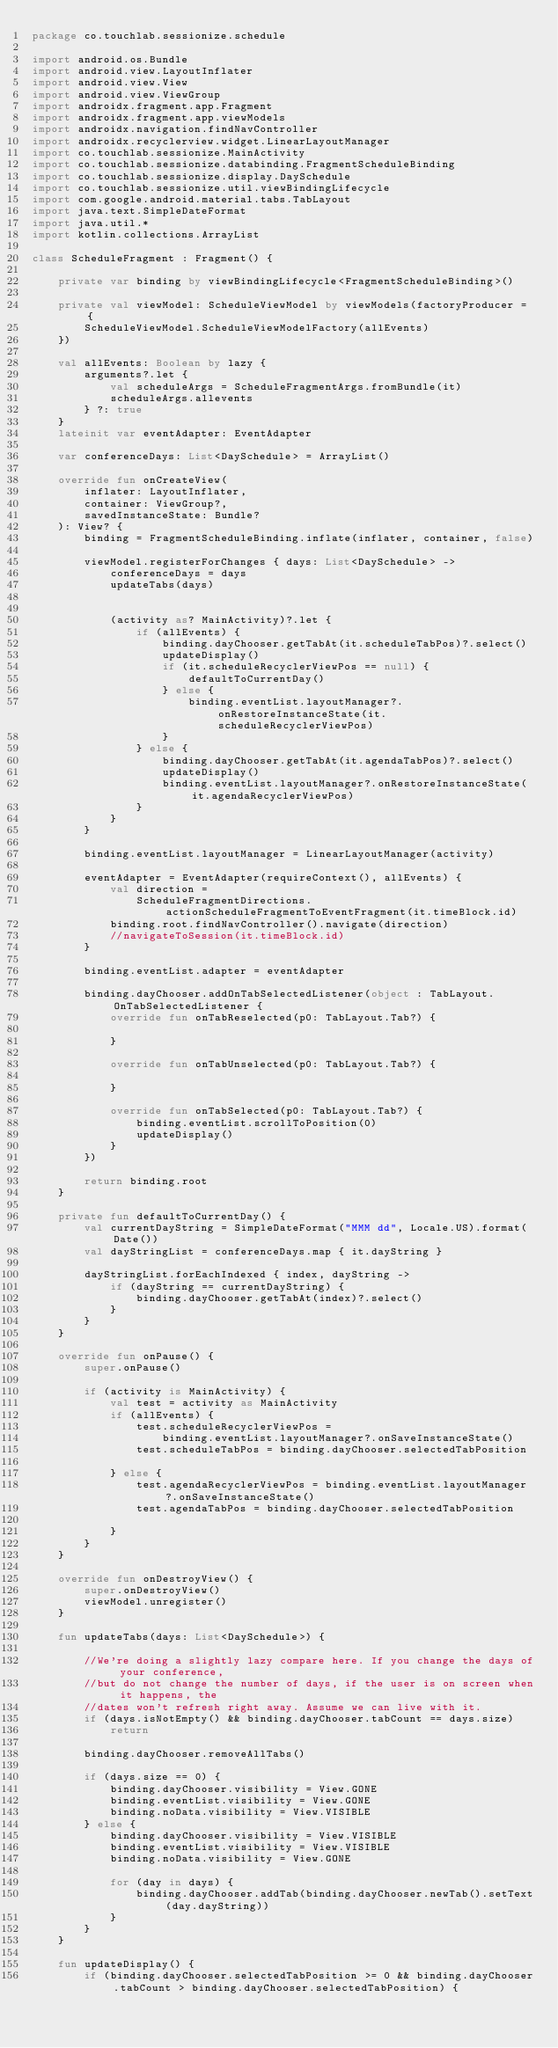<code> <loc_0><loc_0><loc_500><loc_500><_Kotlin_>package co.touchlab.sessionize.schedule

import android.os.Bundle
import android.view.LayoutInflater
import android.view.View
import android.view.ViewGroup
import androidx.fragment.app.Fragment
import androidx.fragment.app.viewModels
import androidx.navigation.findNavController
import androidx.recyclerview.widget.LinearLayoutManager
import co.touchlab.sessionize.MainActivity
import co.touchlab.sessionize.databinding.FragmentScheduleBinding
import co.touchlab.sessionize.display.DaySchedule
import co.touchlab.sessionize.util.viewBindingLifecycle
import com.google.android.material.tabs.TabLayout
import java.text.SimpleDateFormat
import java.util.*
import kotlin.collections.ArrayList

class ScheduleFragment : Fragment() {

    private var binding by viewBindingLifecycle<FragmentScheduleBinding>()

    private val viewModel: ScheduleViewModel by viewModels(factoryProducer = {
        ScheduleViewModel.ScheduleViewModelFactory(allEvents)
    })

    val allEvents: Boolean by lazy {
        arguments?.let {
            val scheduleArgs = ScheduleFragmentArgs.fromBundle(it)
            scheduleArgs.allevents
        } ?: true
    }
    lateinit var eventAdapter: EventAdapter

    var conferenceDays: List<DaySchedule> = ArrayList()

    override fun onCreateView(
        inflater: LayoutInflater,
        container: ViewGroup?,
        savedInstanceState: Bundle?
    ): View? {
        binding = FragmentScheduleBinding.inflate(inflater, container, false)

        viewModel.registerForChanges { days: List<DaySchedule> ->
            conferenceDays = days
            updateTabs(days)


            (activity as? MainActivity)?.let {
                if (allEvents) {
                    binding.dayChooser.getTabAt(it.scheduleTabPos)?.select()
                    updateDisplay()
                    if (it.scheduleRecyclerViewPos == null) {
                        defaultToCurrentDay()
                    } else {
                        binding.eventList.layoutManager?.onRestoreInstanceState(it.scheduleRecyclerViewPos)
                    }
                } else {
                    binding.dayChooser.getTabAt(it.agendaTabPos)?.select()
                    updateDisplay()
                    binding.eventList.layoutManager?.onRestoreInstanceState(it.agendaRecyclerViewPos)
                }
            }
        }

        binding.eventList.layoutManager = LinearLayoutManager(activity)

        eventAdapter = EventAdapter(requireContext(), allEvents) {
            val direction =
                ScheduleFragmentDirections.actionScheduleFragmentToEventFragment(it.timeBlock.id)
            binding.root.findNavController().navigate(direction)
            //navigateToSession(it.timeBlock.id)
        }

        binding.eventList.adapter = eventAdapter

        binding.dayChooser.addOnTabSelectedListener(object : TabLayout.OnTabSelectedListener {
            override fun onTabReselected(p0: TabLayout.Tab?) {

            }

            override fun onTabUnselected(p0: TabLayout.Tab?) {

            }

            override fun onTabSelected(p0: TabLayout.Tab?) {
                binding.eventList.scrollToPosition(0)
                updateDisplay()
            }
        })

        return binding.root
    }

    private fun defaultToCurrentDay() {
        val currentDayString = SimpleDateFormat("MMM dd", Locale.US).format(Date())
        val dayStringList = conferenceDays.map { it.dayString }

        dayStringList.forEachIndexed { index, dayString ->
            if (dayString == currentDayString) {
                binding.dayChooser.getTabAt(index)?.select()
            }
        }
    }

    override fun onPause() {
        super.onPause()

        if (activity is MainActivity) {
            val test = activity as MainActivity
            if (allEvents) {
                test.scheduleRecyclerViewPos =
                    binding.eventList.layoutManager?.onSaveInstanceState()
                test.scheduleTabPos = binding.dayChooser.selectedTabPosition

            } else {
                test.agendaRecyclerViewPos = binding.eventList.layoutManager?.onSaveInstanceState()
                test.agendaTabPos = binding.dayChooser.selectedTabPosition

            }
        }
    }

    override fun onDestroyView() {
        super.onDestroyView()
        viewModel.unregister()
    }

    fun updateTabs(days: List<DaySchedule>) {

        //We're doing a slightly lazy compare here. If you change the days of your conference,
        //but do not change the number of days, if the user is on screen when it happens, the
        //dates won't refresh right away. Assume we can live with it.
        if (days.isNotEmpty() && binding.dayChooser.tabCount == days.size)
            return

        binding.dayChooser.removeAllTabs()

        if (days.size == 0) {
            binding.dayChooser.visibility = View.GONE
            binding.eventList.visibility = View.GONE
            binding.noData.visibility = View.VISIBLE
        } else {
            binding.dayChooser.visibility = View.VISIBLE
            binding.eventList.visibility = View.VISIBLE
            binding.noData.visibility = View.GONE

            for (day in days) {
                binding.dayChooser.addTab(binding.dayChooser.newTab().setText(day.dayString))
            }
        }
    }

    fun updateDisplay() {
        if (binding.dayChooser.selectedTabPosition >= 0 && binding.dayChooser.tabCount > binding.dayChooser.selectedTabPosition) {</code> 